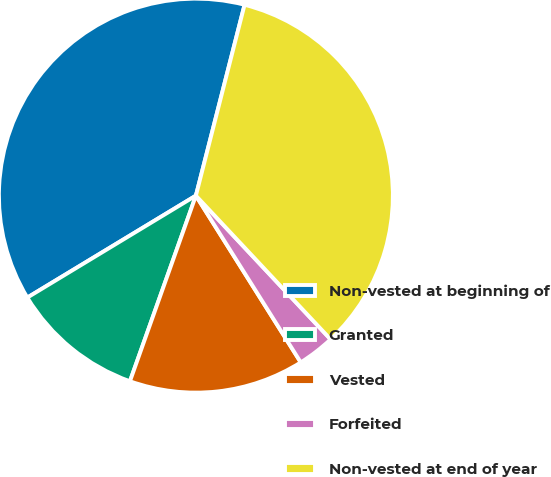Convert chart. <chart><loc_0><loc_0><loc_500><loc_500><pie_chart><fcel>Non-vested at beginning of<fcel>Granted<fcel>Vested<fcel>Forfeited<fcel>Non-vested at end of year<nl><fcel>37.63%<fcel>10.91%<fcel>14.37%<fcel>3.05%<fcel>34.04%<nl></chart> 